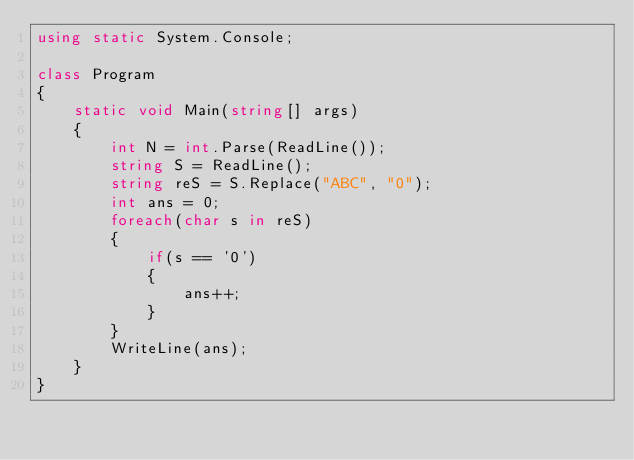<code> <loc_0><loc_0><loc_500><loc_500><_C#_>using static System.Console;

class Program
{
    static void Main(string[] args)
    {
        int N = int.Parse(ReadLine());
        string S = ReadLine();
        string reS = S.Replace("ABC", "0");
        int ans = 0;
        foreach(char s in reS)
        {
            if(s == '0')
            {
                ans++;
            }
        }
        WriteLine(ans);
    }
}</code> 